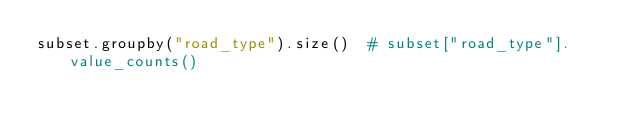Convert code to text. <code><loc_0><loc_0><loc_500><loc_500><_Python_>subset.groupby("road_type").size()  # subset["road_type"].value_counts()</code> 